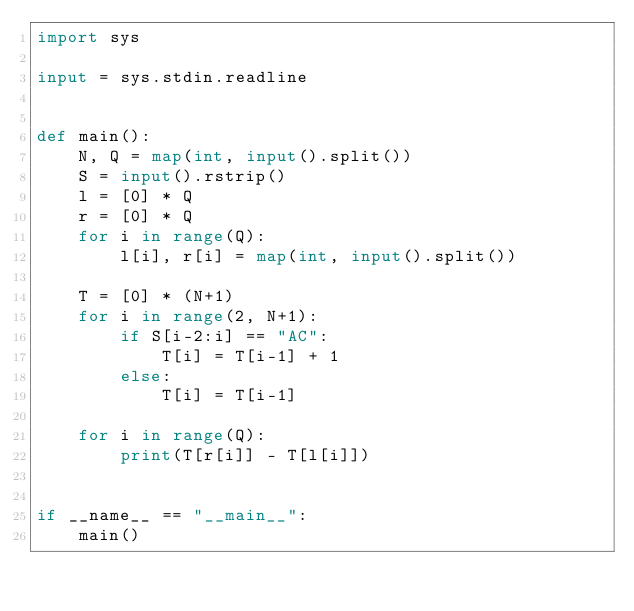Convert code to text. <code><loc_0><loc_0><loc_500><loc_500><_Python_>import sys

input = sys.stdin.readline


def main():
    N, Q = map(int, input().split())
    S = input().rstrip()
    l = [0] * Q
    r = [0] * Q
    for i in range(Q):
        l[i], r[i] = map(int, input().split())

    T = [0] * (N+1)
    for i in range(2, N+1):
        if S[i-2:i] == "AC":
            T[i] = T[i-1] + 1
        else:
            T[i] = T[i-1]

    for i in range(Q):
        print(T[r[i]] - T[l[i]])


if __name__ == "__main__":
    main()
</code> 